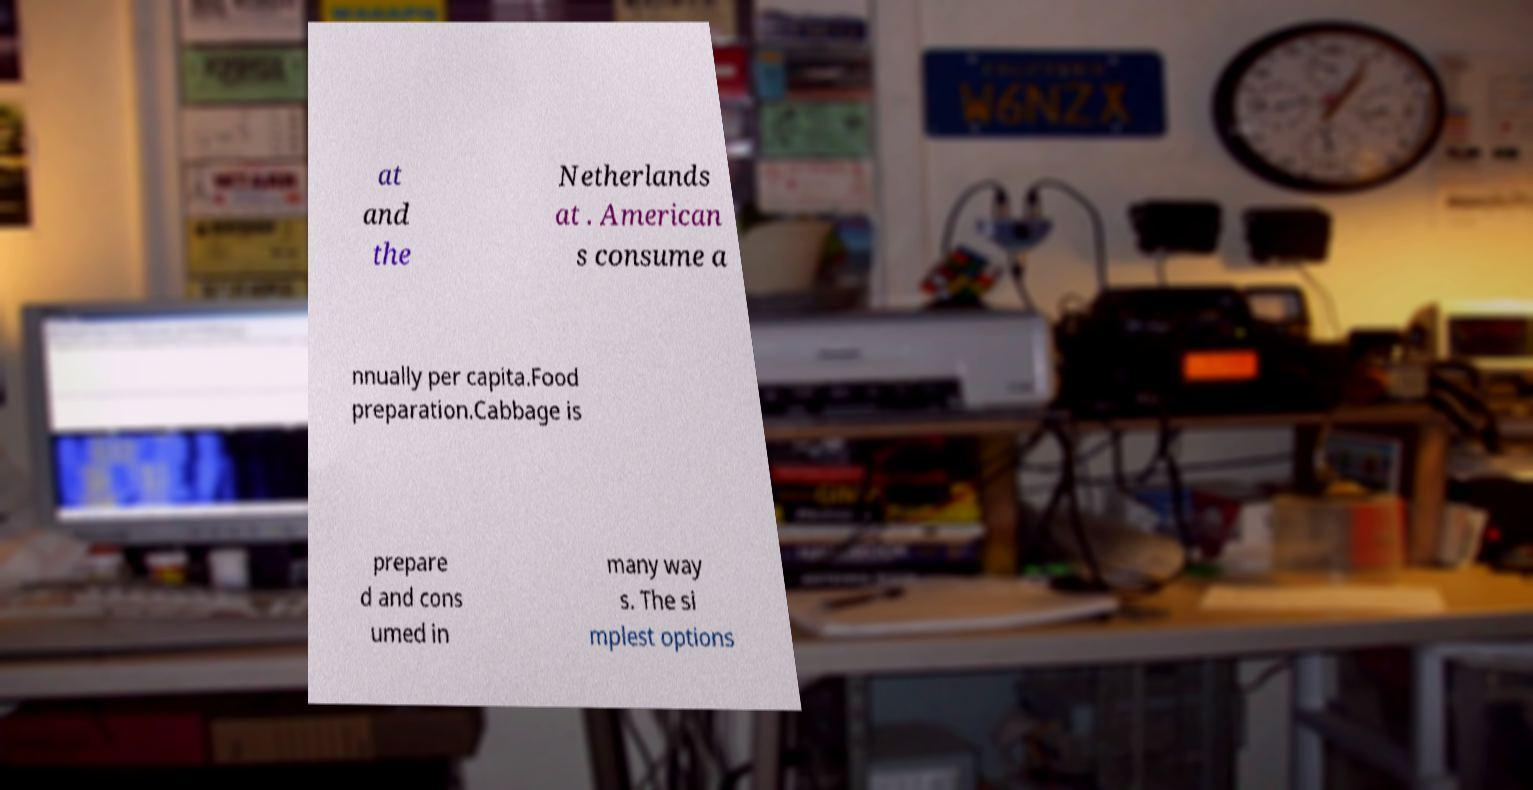What messages or text are displayed in this image? I need them in a readable, typed format. at and the Netherlands at . American s consume a nnually per capita.Food preparation.Cabbage is prepare d and cons umed in many way s. The si mplest options 